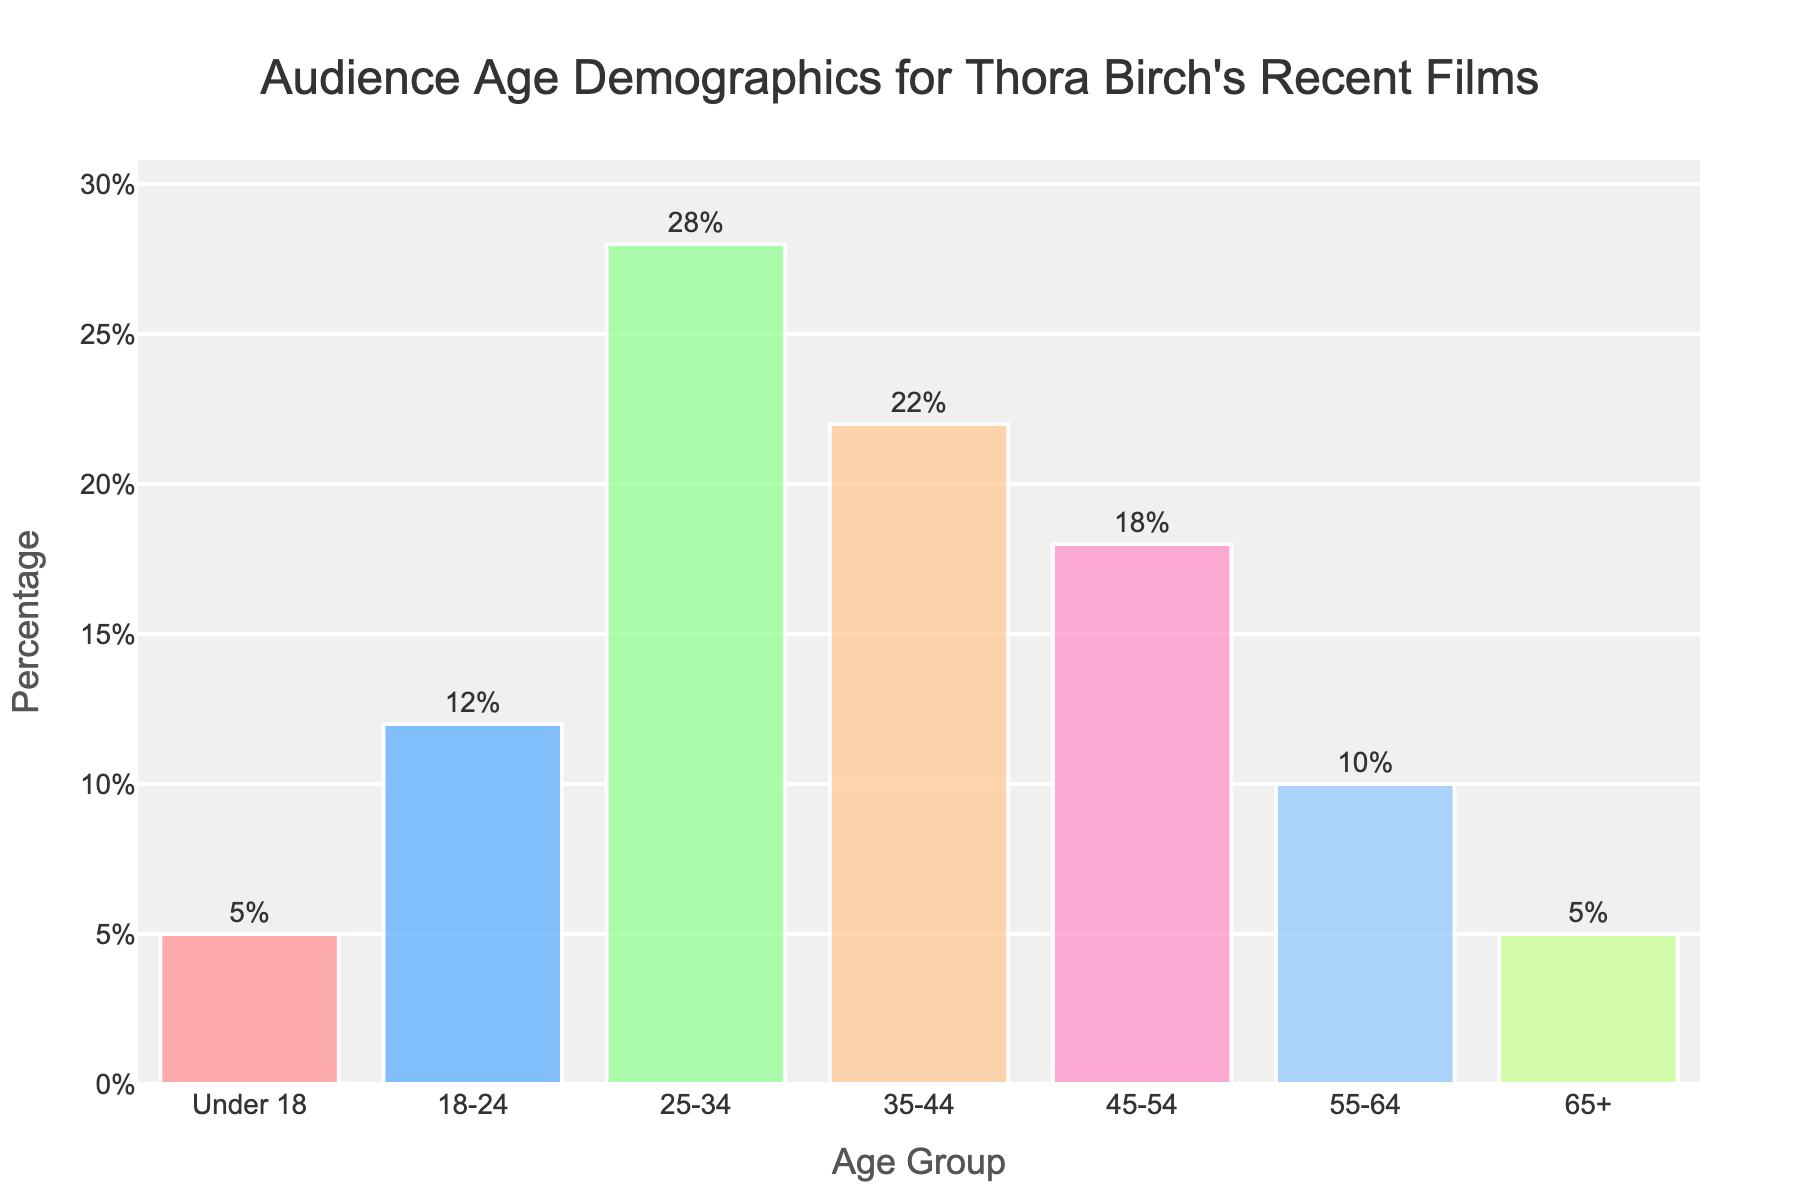What age group has the highest percentage of audience? The highest bar in the chart represents the age group with the largest percentage of audience. The bar for the 25-34 age group is the tallest.
Answer: 25-34 What is the total percentage of audience under 35 years old? Sum the percentages of the age groups under 35: Under 18 (5%) + 18-24 (12%) + 25-34 (28%) = 45%.
Answer: 45% How does the percentage of the 35-44 age group compare to the 45-54 age group? Compare the heights of the bars for these two age groups. The 35-44 age group has a 22% percentage, while the 45-54 age group has 18%. 22% is greater than 18%.
Answer: Greater Which age groups have the lowest audience percentage? Identify the shortest bars in the chart. The bars for Under 18 and 65+ are the shortest, both at 5%.
Answer: Under 18 and 65+ Is the percentage of the 35-44 age group higher or lower than the average percentage across all age groups? Calculate the average: (5 + 12 + 28 + 22 + 18 + 10 + 5) / 7 = 100 / 7 ≈ 14.29%. Compare this with 22%.
Answer: Higher What is the combined percentage of audience aged 45 and above? Sum the percentages for 45-54, 55-64, and 65+: 18% + 10% + 5% = 33%.
Answer: 33% How much higher is the percentage of the 25-34 age group compared to the 55-64 age group? Subtract the percentage of the 55-64 age group from the 25-34 age group: 28% - 10% = 18%.
Answer: 18% Which age group occupies the central position in terms of audience percentage? (i.e., the median age group) Arrange the percentages in ascending order and find the median value. The order is 5%, 5%, 10%, 12%, 18%, 22%, 28%. The median is 12%, corresponding to the 18-24 age group.
Answer: 18-24 